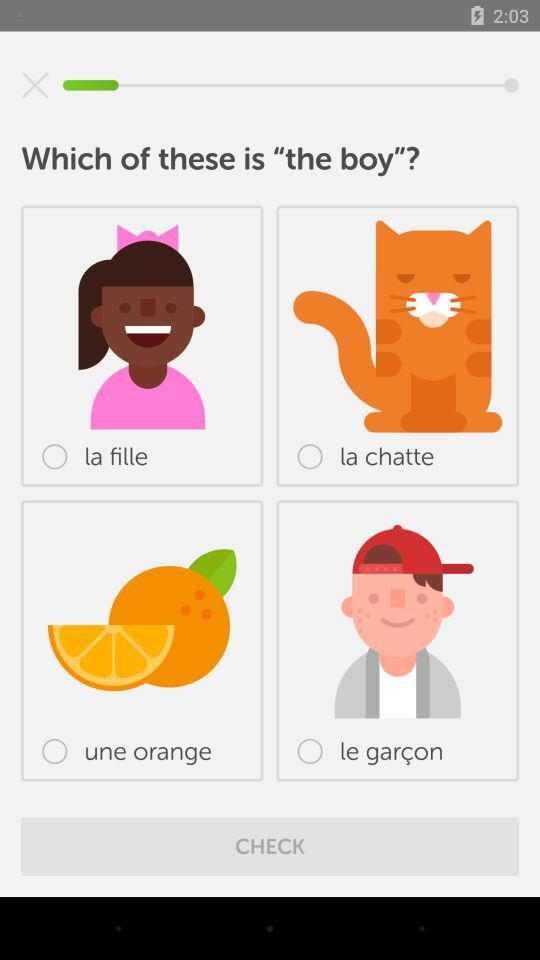Which option is selected?
When the provided information is insufficient, respond with <no answer>. <no answer> 